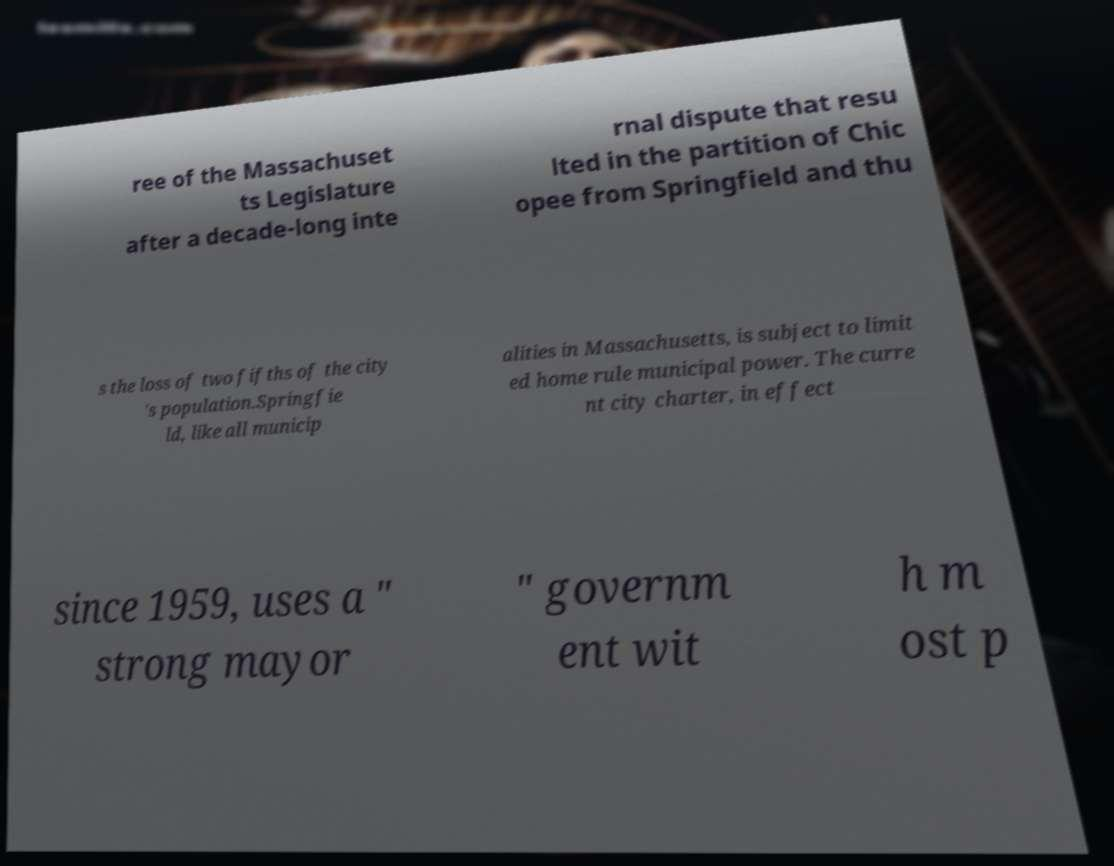Please identify and transcribe the text found in this image. ree of the Massachuset ts Legislature after a decade-long inte rnal dispute that resu lted in the partition of Chic opee from Springfield and thu s the loss of two fifths of the city 's population.Springfie ld, like all municip alities in Massachusetts, is subject to limit ed home rule municipal power. The curre nt city charter, in effect since 1959, uses a " strong mayor " governm ent wit h m ost p 